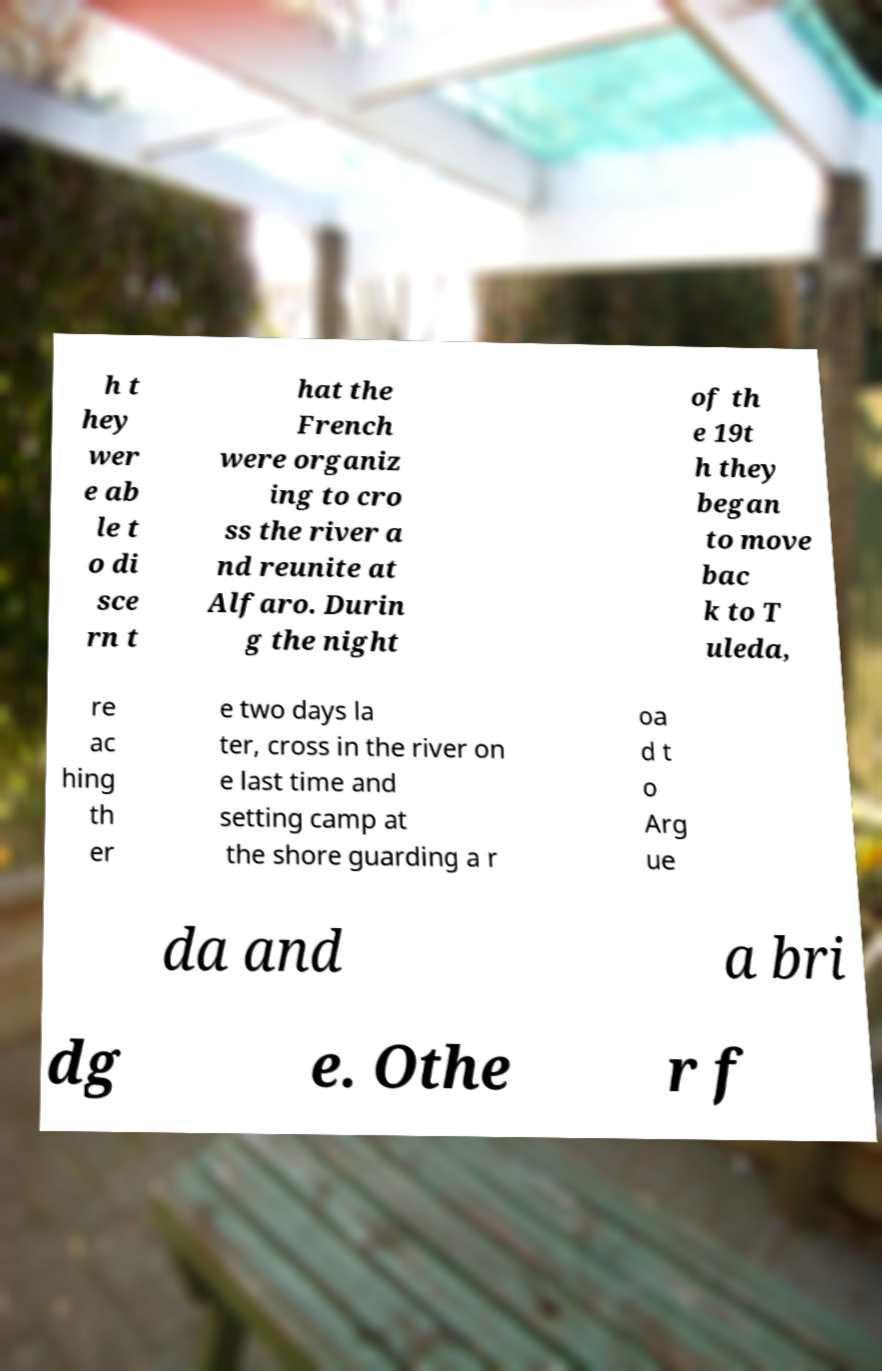There's text embedded in this image that I need extracted. Can you transcribe it verbatim? h t hey wer e ab le t o di sce rn t hat the French were organiz ing to cro ss the river a nd reunite at Alfaro. Durin g the night of th e 19t h they began to move bac k to T uleda, re ac hing th er e two days la ter, cross in the river on e last time and setting camp at the shore guarding a r oa d t o Arg ue da and a bri dg e. Othe r f 